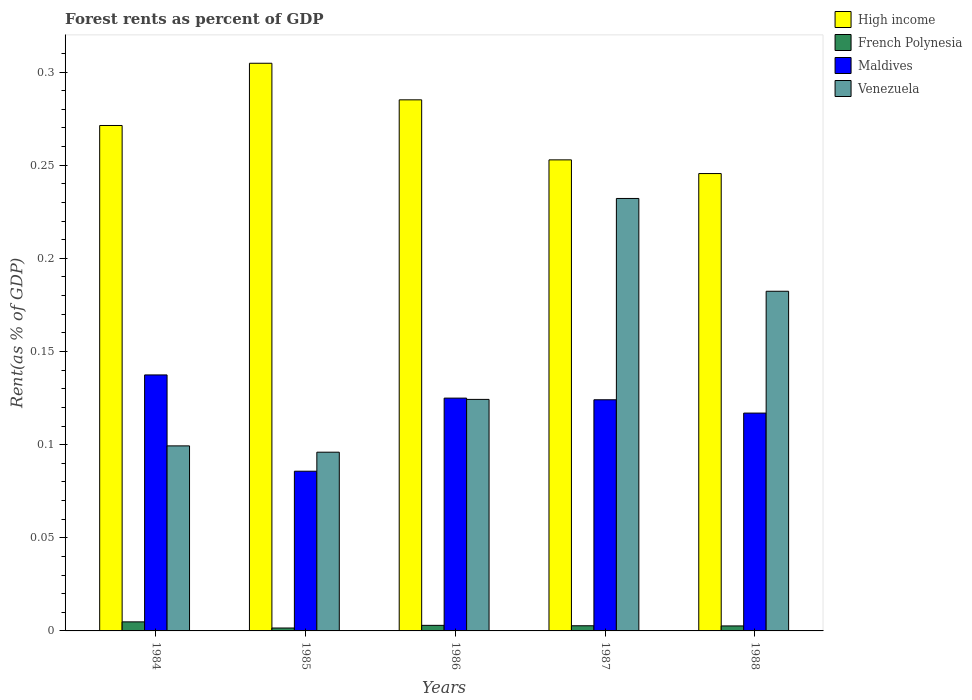How many different coloured bars are there?
Offer a terse response. 4. Are the number of bars per tick equal to the number of legend labels?
Offer a very short reply. Yes. Are the number of bars on each tick of the X-axis equal?
Provide a succinct answer. Yes. How many bars are there on the 1st tick from the right?
Ensure brevity in your answer.  4. What is the forest rent in Venezuela in 1986?
Offer a terse response. 0.12. Across all years, what is the maximum forest rent in High income?
Ensure brevity in your answer.  0.3. Across all years, what is the minimum forest rent in Venezuela?
Make the answer very short. 0.1. In which year was the forest rent in High income minimum?
Provide a succinct answer. 1988. What is the total forest rent in High income in the graph?
Give a very brief answer. 1.36. What is the difference between the forest rent in French Polynesia in 1986 and that in 1988?
Provide a short and direct response. 0. What is the difference between the forest rent in Venezuela in 1988 and the forest rent in High income in 1985?
Give a very brief answer. -0.12. What is the average forest rent in French Polynesia per year?
Provide a short and direct response. 0. In the year 1988, what is the difference between the forest rent in French Polynesia and forest rent in Maldives?
Provide a succinct answer. -0.11. What is the ratio of the forest rent in High income in 1985 to that in 1988?
Give a very brief answer. 1.24. Is the forest rent in Venezuela in 1984 less than that in 1985?
Keep it short and to the point. No. Is the difference between the forest rent in French Polynesia in 1984 and 1988 greater than the difference between the forest rent in Maldives in 1984 and 1988?
Ensure brevity in your answer.  No. What is the difference between the highest and the second highest forest rent in French Polynesia?
Your response must be concise. 0. What is the difference between the highest and the lowest forest rent in High income?
Give a very brief answer. 0.06. In how many years, is the forest rent in Venezuela greater than the average forest rent in Venezuela taken over all years?
Offer a terse response. 2. Is the sum of the forest rent in French Polynesia in 1986 and 1987 greater than the maximum forest rent in Venezuela across all years?
Ensure brevity in your answer.  No. What does the 2nd bar from the left in 1985 represents?
Your response must be concise. French Polynesia. What does the 1st bar from the right in 1987 represents?
Your answer should be compact. Venezuela. Is it the case that in every year, the sum of the forest rent in French Polynesia and forest rent in High income is greater than the forest rent in Maldives?
Provide a short and direct response. Yes. Are all the bars in the graph horizontal?
Make the answer very short. No. How many years are there in the graph?
Provide a succinct answer. 5. What is the difference between two consecutive major ticks on the Y-axis?
Your answer should be compact. 0.05. Are the values on the major ticks of Y-axis written in scientific E-notation?
Your answer should be very brief. No. Does the graph contain grids?
Your response must be concise. No. What is the title of the graph?
Your response must be concise. Forest rents as percent of GDP. Does "Tajikistan" appear as one of the legend labels in the graph?
Offer a terse response. No. What is the label or title of the Y-axis?
Provide a short and direct response. Rent(as % of GDP). What is the Rent(as % of GDP) in High income in 1984?
Offer a terse response. 0.27. What is the Rent(as % of GDP) in French Polynesia in 1984?
Provide a short and direct response. 0. What is the Rent(as % of GDP) of Maldives in 1984?
Make the answer very short. 0.14. What is the Rent(as % of GDP) in Venezuela in 1984?
Give a very brief answer. 0.1. What is the Rent(as % of GDP) in High income in 1985?
Provide a short and direct response. 0.3. What is the Rent(as % of GDP) of French Polynesia in 1985?
Give a very brief answer. 0. What is the Rent(as % of GDP) in Maldives in 1985?
Your answer should be compact. 0.09. What is the Rent(as % of GDP) of Venezuela in 1985?
Offer a very short reply. 0.1. What is the Rent(as % of GDP) in High income in 1986?
Offer a terse response. 0.29. What is the Rent(as % of GDP) in French Polynesia in 1986?
Offer a very short reply. 0. What is the Rent(as % of GDP) of Maldives in 1986?
Keep it short and to the point. 0.12. What is the Rent(as % of GDP) in Venezuela in 1986?
Offer a very short reply. 0.12. What is the Rent(as % of GDP) in High income in 1987?
Your answer should be very brief. 0.25. What is the Rent(as % of GDP) in French Polynesia in 1987?
Give a very brief answer. 0. What is the Rent(as % of GDP) of Maldives in 1987?
Your response must be concise. 0.12. What is the Rent(as % of GDP) in Venezuela in 1987?
Keep it short and to the point. 0.23. What is the Rent(as % of GDP) of High income in 1988?
Your answer should be compact. 0.25. What is the Rent(as % of GDP) in French Polynesia in 1988?
Offer a very short reply. 0. What is the Rent(as % of GDP) of Maldives in 1988?
Offer a terse response. 0.12. What is the Rent(as % of GDP) of Venezuela in 1988?
Offer a very short reply. 0.18. Across all years, what is the maximum Rent(as % of GDP) of High income?
Ensure brevity in your answer.  0.3. Across all years, what is the maximum Rent(as % of GDP) in French Polynesia?
Offer a terse response. 0. Across all years, what is the maximum Rent(as % of GDP) of Maldives?
Give a very brief answer. 0.14. Across all years, what is the maximum Rent(as % of GDP) in Venezuela?
Give a very brief answer. 0.23. Across all years, what is the minimum Rent(as % of GDP) of High income?
Your answer should be very brief. 0.25. Across all years, what is the minimum Rent(as % of GDP) of French Polynesia?
Your answer should be very brief. 0. Across all years, what is the minimum Rent(as % of GDP) of Maldives?
Provide a short and direct response. 0.09. Across all years, what is the minimum Rent(as % of GDP) in Venezuela?
Offer a terse response. 0.1. What is the total Rent(as % of GDP) in High income in the graph?
Your answer should be compact. 1.36. What is the total Rent(as % of GDP) of French Polynesia in the graph?
Ensure brevity in your answer.  0.01. What is the total Rent(as % of GDP) in Maldives in the graph?
Keep it short and to the point. 0.59. What is the total Rent(as % of GDP) in Venezuela in the graph?
Provide a succinct answer. 0.73. What is the difference between the Rent(as % of GDP) of High income in 1984 and that in 1985?
Ensure brevity in your answer.  -0.03. What is the difference between the Rent(as % of GDP) of French Polynesia in 1984 and that in 1985?
Provide a short and direct response. 0. What is the difference between the Rent(as % of GDP) of Maldives in 1984 and that in 1985?
Make the answer very short. 0.05. What is the difference between the Rent(as % of GDP) of Venezuela in 1984 and that in 1985?
Offer a terse response. 0. What is the difference between the Rent(as % of GDP) in High income in 1984 and that in 1986?
Provide a short and direct response. -0.01. What is the difference between the Rent(as % of GDP) in French Polynesia in 1984 and that in 1986?
Offer a very short reply. 0. What is the difference between the Rent(as % of GDP) of Maldives in 1984 and that in 1986?
Offer a very short reply. 0.01. What is the difference between the Rent(as % of GDP) of Venezuela in 1984 and that in 1986?
Keep it short and to the point. -0.03. What is the difference between the Rent(as % of GDP) in High income in 1984 and that in 1987?
Your answer should be compact. 0.02. What is the difference between the Rent(as % of GDP) of French Polynesia in 1984 and that in 1987?
Ensure brevity in your answer.  0. What is the difference between the Rent(as % of GDP) in Maldives in 1984 and that in 1987?
Give a very brief answer. 0.01. What is the difference between the Rent(as % of GDP) in Venezuela in 1984 and that in 1987?
Give a very brief answer. -0.13. What is the difference between the Rent(as % of GDP) of High income in 1984 and that in 1988?
Make the answer very short. 0.03. What is the difference between the Rent(as % of GDP) of French Polynesia in 1984 and that in 1988?
Your answer should be very brief. 0. What is the difference between the Rent(as % of GDP) in Maldives in 1984 and that in 1988?
Offer a very short reply. 0.02. What is the difference between the Rent(as % of GDP) of Venezuela in 1984 and that in 1988?
Give a very brief answer. -0.08. What is the difference between the Rent(as % of GDP) in High income in 1985 and that in 1986?
Give a very brief answer. 0.02. What is the difference between the Rent(as % of GDP) in French Polynesia in 1985 and that in 1986?
Your response must be concise. -0. What is the difference between the Rent(as % of GDP) of Maldives in 1985 and that in 1986?
Ensure brevity in your answer.  -0.04. What is the difference between the Rent(as % of GDP) of Venezuela in 1985 and that in 1986?
Offer a very short reply. -0.03. What is the difference between the Rent(as % of GDP) in High income in 1985 and that in 1987?
Keep it short and to the point. 0.05. What is the difference between the Rent(as % of GDP) of French Polynesia in 1985 and that in 1987?
Ensure brevity in your answer.  -0. What is the difference between the Rent(as % of GDP) in Maldives in 1985 and that in 1987?
Provide a succinct answer. -0.04. What is the difference between the Rent(as % of GDP) in Venezuela in 1985 and that in 1987?
Make the answer very short. -0.14. What is the difference between the Rent(as % of GDP) in High income in 1985 and that in 1988?
Your response must be concise. 0.06. What is the difference between the Rent(as % of GDP) of French Polynesia in 1985 and that in 1988?
Make the answer very short. -0. What is the difference between the Rent(as % of GDP) in Maldives in 1985 and that in 1988?
Your answer should be very brief. -0.03. What is the difference between the Rent(as % of GDP) of Venezuela in 1985 and that in 1988?
Your response must be concise. -0.09. What is the difference between the Rent(as % of GDP) in High income in 1986 and that in 1987?
Ensure brevity in your answer.  0.03. What is the difference between the Rent(as % of GDP) of Maldives in 1986 and that in 1987?
Offer a terse response. 0. What is the difference between the Rent(as % of GDP) in Venezuela in 1986 and that in 1987?
Keep it short and to the point. -0.11. What is the difference between the Rent(as % of GDP) in High income in 1986 and that in 1988?
Make the answer very short. 0.04. What is the difference between the Rent(as % of GDP) in Maldives in 1986 and that in 1988?
Your answer should be very brief. 0.01. What is the difference between the Rent(as % of GDP) in Venezuela in 1986 and that in 1988?
Offer a terse response. -0.06. What is the difference between the Rent(as % of GDP) of High income in 1987 and that in 1988?
Your response must be concise. 0.01. What is the difference between the Rent(as % of GDP) in French Polynesia in 1987 and that in 1988?
Your answer should be compact. 0. What is the difference between the Rent(as % of GDP) of Maldives in 1987 and that in 1988?
Ensure brevity in your answer.  0.01. What is the difference between the Rent(as % of GDP) in Venezuela in 1987 and that in 1988?
Offer a terse response. 0.05. What is the difference between the Rent(as % of GDP) in High income in 1984 and the Rent(as % of GDP) in French Polynesia in 1985?
Your response must be concise. 0.27. What is the difference between the Rent(as % of GDP) in High income in 1984 and the Rent(as % of GDP) in Maldives in 1985?
Provide a short and direct response. 0.19. What is the difference between the Rent(as % of GDP) in High income in 1984 and the Rent(as % of GDP) in Venezuela in 1985?
Provide a succinct answer. 0.18. What is the difference between the Rent(as % of GDP) of French Polynesia in 1984 and the Rent(as % of GDP) of Maldives in 1985?
Your response must be concise. -0.08. What is the difference between the Rent(as % of GDP) of French Polynesia in 1984 and the Rent(as % of GDP) of Venezuela in 1985?
Offer a terse response. -0.09. What is the difference between the Rent(as % of GDP) in Maldives in 1984 and the Rent(as % of GDP) in Venezuela in 1985?
Ensure brevity in your answer.  0.04. What is the difference between the Rent(as % of GDP) of High income in 1984 and the Rent(as % of GDP) of French Polynesia in 1986?
Give a very brief answer. 0.27. What is the difference between the Rent(as % of GDP) of High income in 1984 and the Rent(as % of GDP) of Maldives in 1986?
Your answer should be compact. 0.15. What is the difference between the Rent(as % of GDP) of High income in 1984 and the Rent(as % of GDP) of Venezuela in 1986?
Provide a short and direct response. 0.15. What is the difference between the Rent(as % of GDP) of French Polynesia in 1984 and the Rent(as % of GDP) of Maldives in 1986?
Keep it short and to the point. -0.12. What is the difference between the Rent(as % of GDP) of French Polynesia in 1984 and the Rent(as % of GDP) of Venezuela in 1986?
Keep it short and to the point. -0.12. What is the difference between the Rent(as % of GDP) of Maldives in 1984 and the Rent(as % of GDP) of Venezuela in 1986?
Provide a succinct answer. 0.01. What is the difference between the Rent(as % of GDP) of High income in 1984 and the Rent(as % of GDP) of French Polynesia in 1987?
Your answer should be compact. 0.27. What is the difference between the Rent(as % of GDP) of High income in 1984 and the Rent(as % of GDP) of Maldives in 1987?
Keep it short and to the point. 0.15. What is the difference between the Rent(as % of GDP) in High income in 1984 and the Rent(as % of GDP) in Venezuela in 1987?
Make the answer very short. 0.04. What is the difference between the Rent(as % of GDP) in French Polynesia in 1984 and the Rent(as % of GDP) in Maldives in 1987?
Provide a short and direct response. -0.12. What is the difference between the Rent(as % of GDP) in French Polynesia in 1984 and the Rent(as % of GDP) in Venezuela in 1987?
Provide a succinct answer. -0.23. What is the difference between the Rent(as % of GDP) of Maldives in 1984 and the Rent(as % of GDP) of Venezuela in 1987?
Ensure brevity in your answer.  -0.09. What is the difference between the Rent(as % of GDP) of High income in 1984 and the Rent(as % of GDP) of French Polynesia in 1988?
Your answer should be very brief. 0.27. What is the difference between the Rent(as % of GDP) of High income in 1984 and the Rent(as % of GDP) of Maldives in 1988?
Ensure brevity in your answer.  0.15. What is the difference between the Rent(as % of GDP) in High income in 1984 and the Rent(as % of GDP) in Venezuela in 1988?
Give a very brief answer. 0.09. What is the difference between the Rent(as % of GDP) of French Polynesia in 1984 and the Rent(as % of GDP) of Maldives in 1988?
Your answer should be very brief. -0.11. What is the difference between the Rent(as % of GDP) of French Polynesia in 1984 and the Rent(as % of GDP) of Venezuela in 1988?
Offer a very short reply. -0.18. What is the difference between the Rent(as % of GDP) of Maldives in 1984 and the Rent(as % of GDP) of Venezuela in 1988?
Offer a terse response. -0.04. What is the difference between the Rent(as % of GDP) of High income in 1985 and the Rent(as % of GDP) of French Polynesia in 1986?
Make the answer very short. 0.3. What is the difference between the Rent(as % of GDP) of High income in 1985 and the Rent(as % of GDP) of Maldives in 1986?
Offer a very short reply. 0.18. What is the difference between the Rent(as % of GDP) in High income in 1985 and the Rent(as % of GDP) in Venezuela in 1986?
Ensure brevity in your answer.  0.18. What is the difference between the Rent(as % of GDP) of French Polynesia in 1985 and the Rent(as % of GDP) of Maldives in 1986?
Keep it short and to the point. -0.12. What is the difference between the Rent(as % of GDP) of French Polynesia in 1985 and the Rent(as % of GDP) of Venezuela in 1986?
Keep it short and to the point. -0.12. What is the difference between the Rent(as % of GDP) of Maldives in 1985 and the Rent(as % of GDP) of Venezuela in 1986?
Make the answer very short. -0.04. What is the difference between the Rent(as % of GDP) in High income in 1985 and the Rent(as % of GDP) in French Polynesia in 1987?
Ensure brevity in your answer.  0.3. What is the difference between the Rent(as % of GDP) in High income in 1985 and the Rent(as % of GDP) in Maldives in 1987?
Give a very brief answer. 0.18. What is the difference between the Rent(as % of GDP) of High income in 1985 and the Rent(as % of GDP) of Venezuela in 1987?
Your answer should be compact. 0.07. What is the difference between the Rent(as % of GDP) in French Polynesia in 1985 and the Rent(as % of GDP) in Maldives in 1987?
Offer a terse response. -0.12. What is the difference between the Rent(as % of GDP) of French Polynesia in 1985 and the Rent(as % of GDP) of Venezuela in 1987?
Make the answer very short. -0.23. What is the difference between the Rent(as % of GDP) in Maldives in 1985 and the Rent(as % of GDP) in Venezuela in 1987?
Provide a succinct answer. -0.15. What is the difference between the Rent(as % of GDP) of High income in 1985 and the Rent(as % of GDP) of French Polynesia in 1988?
Your answer should be very brief. 0.3. What is the difference between the Rent(as % of GDP) of High income in 1985 and the Rent(as % of GDP) of Maldives in 1988?
Give a very brief answer. 0.19. What is the difference between the Rent(as % of GDP) of High income in 1985 and the Rent(as % of GDP) of Venezuela in 1988?
Offer a terse response. 0.12. What is the difference between the Rent(as % of GDP) in French Polynesia in 1985 and the Rent(as % of GDP) in Maldives in 1988?
Give a very brief answer. -0.12. What is the difference between the Rent(as % of GDP) of French Polynesia in 1985 and the Rent(as % of GDP) of Venezuela in 1988?
Your response must be concise. -0.18. What is the difference between the Rent(as % of GDP) of Maldives in 1985 and the Rent(as % of GDP) of Venezuela in 1988?
Provide a short and direct response. -0.1. What is the difference between the Rent(as % of GDP) of High income in 1986 and the Rent(as % of GDP) of French Polynesia in 1987?
Give a very brief answer. 0.28. What is the difference between the Rent(as % of GDP) of High income in 1986 and the Rent(as % of GDP) of Maldives in 1987?
Ensure brevity in your answer.  0.16. What is the difference between the Rent(as % of GDP) in High income in 1986 and the Rent(as % of GDP) in Venezuela in 1987?
Your answer should be compact. 0.05. What is the difference between the Rent(as % of GDP) in French Polynesia in 1986 and the Rent(as % of GDP) in Maldives in 1987?
Your answer should be very brief. -0.12. What is the difference between the Rent(as % of GDP) in French Polynesia in 1986 and the Rent(as % of GDP) in Venezuela in 1987?
Offer a terse response. -0.23. What is the difference between the Rent(as % of GDP) of Maldives in 1986 and the Rent(as % of GDP) of Venezuela in 1987?
Your answer should be compact. -0.11. What is the difference between the Rent(as % of GDP) of High income in 1986 and the Rent(as % of GDP) of French Polynesia in 1988?
Offer a terse response. 0.28. What is the difference between the Rent(as % of GDP) of High income in 1986 and the Rent(as % of GDP) of Maldives in 1988?
Offer a very short reply. 0.17. What is the difference between the Rent(as % of GDP) in High income in 1986 and the Rent(as % of GDP) in Venezuela in 1988?
Ensure brevity in your answer.  0.1. What is the difference between the Rent(as % of GDP) in French Polynesia in 1986 and the Rent(as % of GDP) in Maldives in 1988?
Keep it short and to the point. -0.11. What is the difference between the Rent(as % of GDP) in French Polynesia in 1986 and the Rent(as % of GDP) in Venezuela in 1988?
Your response must be concise. -0.18. What is the difference between the Rent(as % of GDP) in Maldives in 1986 and the Rent(as % of GDP) in Venezuela in 1988?
Give a very brief answer. -0.06. What is the difference between the Rent(as % of GDP) of High income in 1987 and the Rent(as % of GDP) of French Polynesia in 1988?
Ensure brevity in your answer.  0.25. What is the difference between the Rent(as % of GDP) of High income in 1987 and the Rent(as % of GDP) of Maldives in 1988?
Offer a terse response. 0.14. What is the difference between the Rent(as % of GDP) in High income in 1987 and the Rent(as % of GDP) in Venezuela in 1988?
Give a very brief answer. 0.07. What is the difference between the Rent(as % of GDP) in French Polynesia in 1987 and the Rent(as % of GDP) in Maldives in 1988?
Your answer should be compact. -0.11. What is the difference between the Rent(as % of GDP) in French Polynesia in 1987 and the Rent(as % of GDP) in Venezuela in 1988?
Your answer should be compact. -0.18. What is the difference between the Rent(as % of GDP) of Maldives in 1987 and the Rent(as % of GDP) of Venezuela in 1988?
Your answer should be compact. -0.06. What is the average Rent(as % of GDP) in High income per year?
Provide a short and direct response. 0.27. What is the average Rent(as % of GDP) in French Polynesia per year?
Your answer should be very brief. 0. What is the average Rent(as % of GDP) in Maldives per year?
Provide a short and direct response. 0.12. What is the average Rent(as % of GDP) in Venezuela per year?
Give a very brief answer. 0.15. In the year 1984, what is the difference between the Rent(as % of GDP) in High income and Rent(as % of GDP) in French Polynesia?
Provide a short and direct response. 0.27. In the year 1984, what is the difference between the Rent(as % of GDP) of High income and Rent(as % of GDP) of Maldives?
Provide a succinct answer. 0.13. In the year 1984, what is the difference between the Rent(as % of GDP) in High income and Rent(as % of GDP) in Venezuela?
Provide a short and direct response. 0.17. In the year 1984, what is the difference between the Rent(as % of GDP) in French Polynesia and Rent(as % of GDP) in Maldives?
Your answer should be very brief. -0.13. In the year 1984, what is the difference between the Rent(as % of GDP) of French Polynesia and Rent(as % of GDP) of Venezuela?
Provide a succinct answer. -0.09. In the year 1984, what is the difference between the Rent(as % of GDP) of Maldives and Rent(as % of GDP) of Venezuela?
Keep it short and to the point. 0.04. In the year 1985, what is the difference between the Rent(as % of GDP) of High income and Rent(as % of GDP) of French Polynesia?
Your answer should be very brief. 0.3. In the year 1985, what is the difference between the Rent(as % of GDP) of High income and Rent(as % of GDP) of Maldives?
Your response must be concise. 0.22. In the year 1985, what is the difference between the Rent(as % of GDP) of High income and Rent(as % of GDP) of Venezuela?
Offer a very short reply. 0.21. In the year 1985, what is the difference between the Rent(as % of GDP) in French Polynesia and Rent(as % of GDP) in Maldives?
Provide a short and direct response. -0.08. In the year 1985, what is the difference between the Rent(as % of GDP) of French Polynesia and Rent(as % of GDP) of Venezuela?
Give a very brief answer. -0.09. In the year 1985, what is the difference between the Rent(as % of GDP) in Maldives and Rent(as % of GDP) in Venezuela?
Keep it short and to the point. -0.01. In the year 1986, what is the difference between the Rent(as % of GDP) of High income and Rent(as % of GDP) of French Polynesia?
Offer a terse response. 0.28. In the year 1986, what is the difference between the Rent(as % of GDP) of High income and Rent(as % of GDP) of Maldives?
Offer a terse response. 0.16. In the year 1986, what is the difference between the Rent(as % of GDP) of High income and Rent(as % of GDP) of Venezuela?
Your answer should be very brief. 0.16. In the year 1986, what is the difference between the Rent(as % of GDP) of French Polynesia and Rent(as % of GDP) of Maldives?
Your answer should be compact. -0.12. In the year 1986, what is the difference between the Rent(as % of GDP) in French Polynesia and Rent(as % of GDP) in Venezuela?
Your answer should be very brief. -0.12. In the year 1986, what is the difference between the Rent(as % of GDP) of Maldives and Rent(as % of GDP) of Venezuela?
Offer a terse response. 0. In the year 1987, what is the difference between the Rent(as % of GDP) in High income and Rent(as % of GDP) in French Polynesia?
Your answer should be compact. 0.25. In the year 1987, what is the difference between the Rent(as % of GDP) of High income and Rent(as % of GDP) of Maldives?
Your response must be concise. 0.13. In the year 1987, what is the difference between the Rent(as % of GDP) of High income and Rent(as % of GDP) of Venezuela?
Provide a succinct answer. 0.02. In the year 1987, what is the difference between the Rent(as % of GDP) of French Polynesia and Rent(as % of GDP) of Maldives?
Your response must be concise. -0.12. In the year 1987, what is the difference between the Rent(as % of GDP) in French Polynesia and Rent(as % of GDP) in Venezuela?
Offer a terse response. -0.23. In the year 1987, what is the difference between the Rent(as % of GDP) in Maldives and Rent(as % of GDP) in Venezuela?
Your answer should be compact. -0.11. In the year 1988, what is the difference between the Rent(as % of GDP) in High income and Rent(as % of GDP) in French Polynesia?
Your response must be concise. 0.24. In the year 1988, what is the difference between the Rent(as % of GDP) in High income and Rent(as % of GDP) in Maldives?
Keep it short and to the point. 0.13. In the year 1988, what is the difference between the Rent(as % of GDP) of High income and Rent(as % of GDP) of Venezuela?
Your answer should be very brief. 0.06. In the year 1988, what is the difference between the Rent(as % of GDP) in French Polynesia and Rent(as % of GDP) in Maldives?
Keep it short and to the point. -0.11. In the year 1988, what is the difference between the Rent(as % of GDP) of French Polynesia and Rent(as % of GDP) of Venezuela?
Offer a terse response. -0.18. In the year 1988, what is the difference between the Rent(as % of GDP) in Maldives and Rent(as % of GDP) in Venezuela?
Provide a succinct answer. -0.07. What is the ratio of the Rent(as % of GDP) in High income in 1984 to that in 1985?
Your answer should be very brief. 0.89. What is the ratio of the Rent(as % of GDP) in French Polynesia in 1984 to that in 1985?
Your response must be concise. 3.11. What is the ratio of the Rent(as % of GDP) in Maldives in 1984 to that in 1985?
Make the answer very short. 1.6. What is the ratio of the Rent(as % of GDP) in Venezuela in 1984 to that in 1985?
Your response must be concise. 1.04. What is the ratio of the Rent(as % of GDP) of High income in 1984 to that in 1986?
Offer a terse response. 0.95. What is the ratio of the Rent(as % of GDP) in French Polynesia in 1984 to that in 1986?
Provide a short and direct response. 1.62. What is the ratio of the Rent(as % of GDP) in Maldives in 1984 to that in 1986?
Offer a terse response. 1.1. What is the ratio of the Rent(as % of GDP) in Venezuela in 1984 to that in 1986?
Offer a terse response. 0.8. What is the ratio of the Rent(as % of GDP) in High income in 1984 to that in 1987?
Your answer should be very brief. 1.07. What is the ratio of the Rent(as % of GDP) in French Polynesia in 1984 to that in 1987?
Your answer should be compact. 1.76. What is the ratio of the Rent(as % of GDP) in Maldives in 1984 to that in 1987?
Your response must be concise. 1.11. What is the ratio of the Rent(as % of GDP) of Venezuela in 1984 to that in 1987?
Your answer should be compact. 0.43. What is the ratio of the Rent(as % of GDP) in High income in 1984 to that in 1988?
Make the answer very short. 1.11. What is the ratio of the Rent(as % of GDP) in French Polynesia in 1984 to that in 1988?
Your answer should be compact. 1.81. What is the ratio of the Rent(as % of GDP) of Maldives in 1984 to that in 1988?
Offer a terse response. 1.18. What is the ratio of the Rent(as % of GDP) of Venezuela in 1984 to that in 1988?
Provide a succinct answer. 0.54. What is the ratio of the Rent(as % of GDP) of High income in 1985 to that in 1986?
Keep it short and to the point. 1.07. What is the ratio of the Rent(as % of GDP) in French Polynesia in 1985 to that in 1986?
Keep it short and to the point. 0.52. What is the ratio of the Rent(as % of GDP) of Maldives in 1985 to that in 1986?
Offer a terse response. 0.69. What is the ratio of the Rent(as % of GDP) of Venezuela in 1985 to that in 1986?
Keep it short and to the point. 0.77. What is the ratio of the Rent(as % of GDP) of High income in 1985 to that in 1987?
Give a very brief answer. 1.21. What is the ratio of the Rent(as % of GDP) of French Polynesia in 1985 to that in 1987?
Give a very brief answer. 0.56. What is the ratio of the Rent(as % of GDP) of Maldives in 1985 to that in 1987?
Provide a succinct answer. 0.69. What is the ratio of the Rent(as % of GDP) of Venezuela in 1985 to that in 1987?
Offer a terse response. 0.41. What is the ratio of the Rent(as % of GDP) of High income in 1985 to that in 1988?
Ensure brevity in your answer.  1.24. What is the ratio of the Rent(as % of GDP) of French Polynesia in 1985 to that in 1988?
Provide a succinct answer. 0.58. What is the ratio of the Rent(as % of GDP) of Maldives in 1985 to that in 1988?
Your answer should be very brief. 0.73. What is the ratio of the Rent(as % of GDP) of Venezuela in 1985 to that in 1988?
Offer a terse response. 0.53. What is the ratio of the Rent(as % of GDP) of High income in 1986 to that in 1987?
Offer a terse response. 1.13. What is the ratio of the Rent(as % of GDP) of French Polynesia in 1986 to that in 1987?
Keep it short and to the point. 1.08. What is the ratio of the Rent(as % of GDP) in Maldives in 1986 to that in 1987?
Give a very brief answer. 1.01. What is the ratio of the Rent(as % of GDP) of Venezuela in 1986 to that in 1987?
Ensure brevity in your answer.  0.54. What is the ratio of the Rent(as % of GDP) of High income in 1986 to that in 1988?
Keep it short and to the point. 1.16. What is the ratio of the Rent(as % of GDP) in French Polynesia in 1986 to that in 1988?
Offer a terse response. 1.12. What is the ratio of the Rent(as % of GDP) in Maldives in 1986 to that in 1988?
Keep it short and to the point. 1.07. What is the ratio of the Rent(as % of GDP) of Venezuela in 1986 to that in 1988?
Provide a short and direct response. 0.68. What is the ratio of the Rent(as % of GDP) in High income in 1987 to that in 1988?
Ensure brevity in your answer.  1.03. What is the ratio of the Rent(as % of GDP) in French Polynesia in 1987 to that in 1988?
Make the answer very short. 1.03. What is the ratio of the Rent(as % of GDP) in Maldives in 1987 to that in 1988?
Your answer should be compact. 1.06. What is the ratio of the Rent(as % of GDP) of Venezuela in 1987 to that in 1988?
Ensure brevity in your answer.  1.27. What is the difference between the highest and the second highest Rent(as % of GDP) of High income?
Provide a succinct answer. 0.02. What is the difference between the highest and the second highest Rent(as % of GDP) in French Polynesia?
Offer a terse response. 0. What is the difference between the highest and the second highest Rent(as % of GDP) of Maldives?
Make the answer very short. 0.01. What is the difference between the highest and the second highest Rent(as % of GDP) of Venezuela?
Keep it short and to the point. 0.05. What is the difference between the highest and the lowest Rent(as % of GDP) of High income?
Your answer should be compact. 0.06. What is the difference between the highest and the lowest Rent(as % of GDP) in French Polynesia?
Give a very brief answer. 0. What is the difference between the highest and the lowest Rent(as % of GDP) of Maldives?
Ensure brevity in your answer.  0.05. What is the difference between the highest and the lowest Rent(as % of GDP) in Venezuela?
Give a very brief answer. 0.14. 